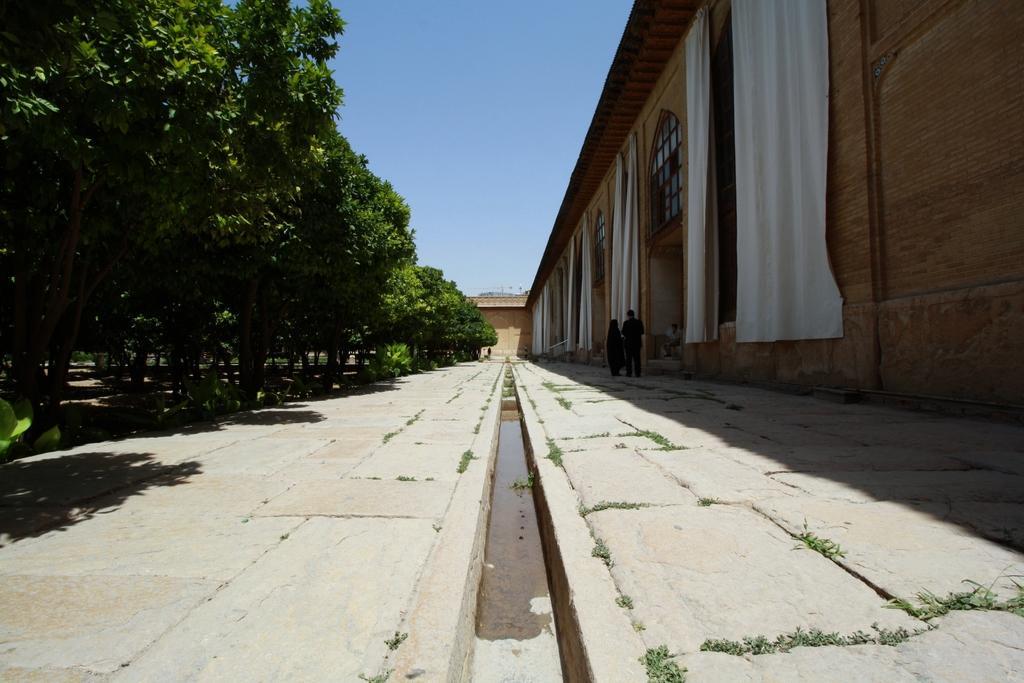Can you describe this image briefly? This picture is taken from outside of the city and it is sunny. In this image, on the right side, we can see a building, curtains and two people are standing on the floor. On the left side, we can see few trees. In the background, we can see a building. At the top, we can see a sky, at the bottom, we can see a land. 